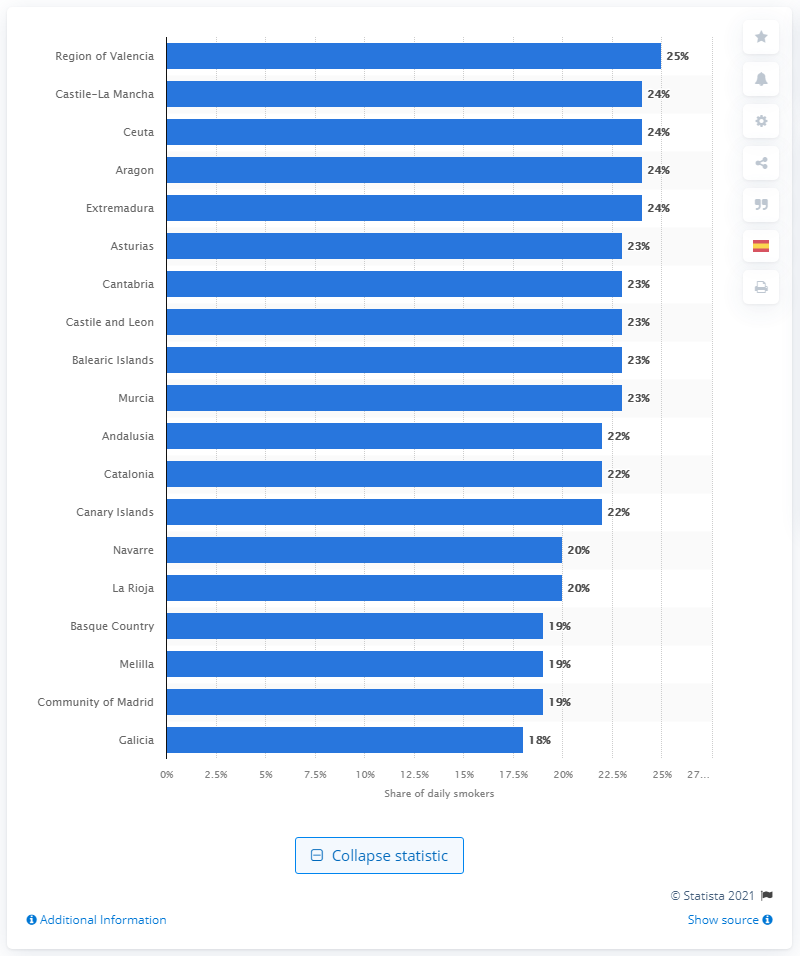Give some essential details in this illustration. The prevalence of tobacco use was high in most Spanish regions during the 20th century. The Spanish autonomous community of Andalusia had the highest number of smokers. 